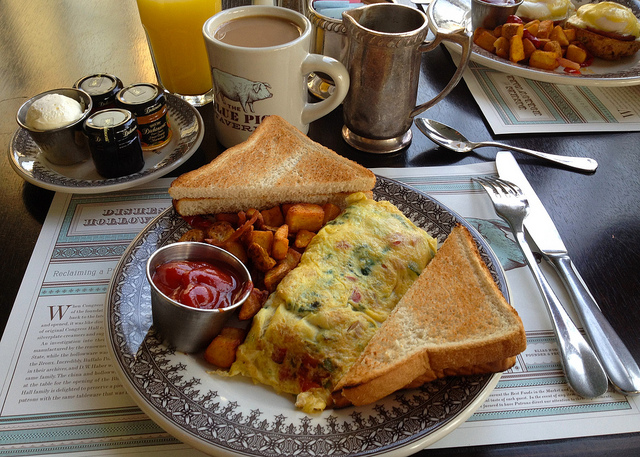Extract all visible text content from this image. RECLAIMING W LUE HOLLOW 